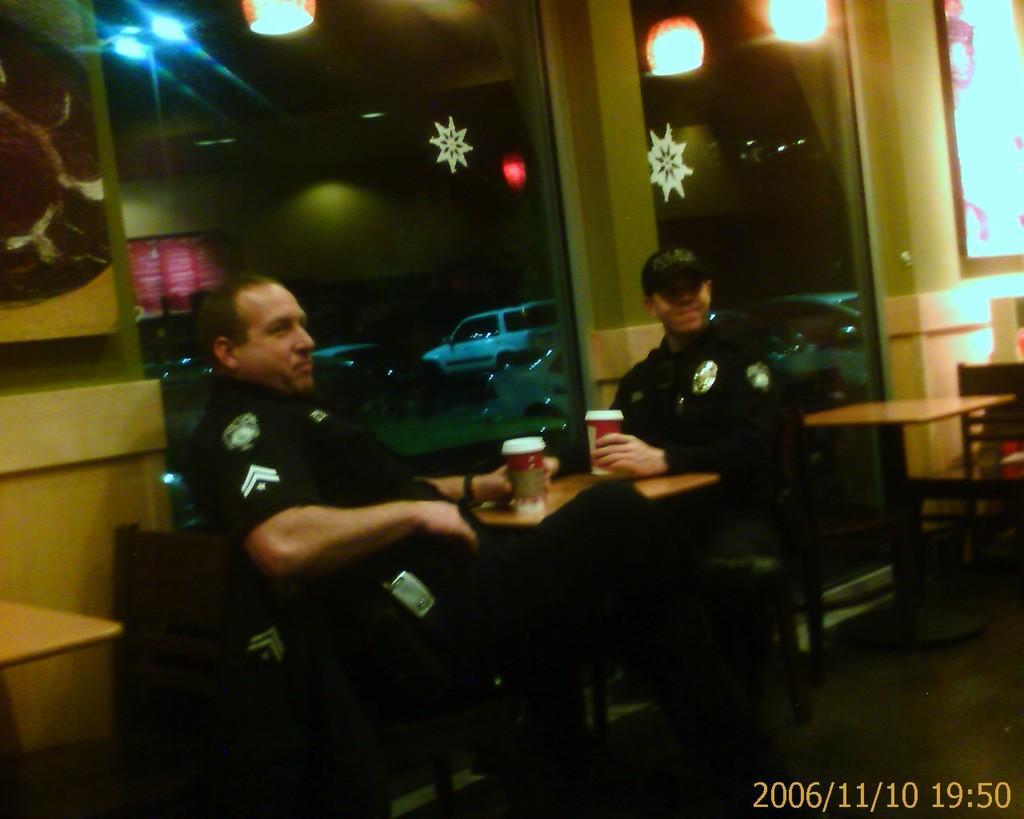Describe this image in one or two sentences. In this image we can see people sitting and holding glasses. There are tables. In the background there are vehicles and lights. We can see a wall. 